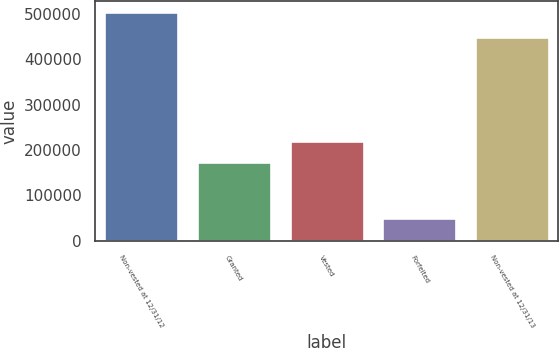Convert chart to OTSL. <chart><loc_0><loc_0><loc_500><loc_500><bar_chart><fcel>Non-vested at 12/31/12<fcel>Granted<fcel>Vested<fcel>Forfeited<fcel>Non-vested at 12/31/13<nl><fcel>502701<fcel>174019<fcel>219325<fcel>49645<fcel>448526<nl></chart> 